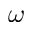<formula> <loc_0><loc_0><loc_500><loc_500>\omega</formula> 